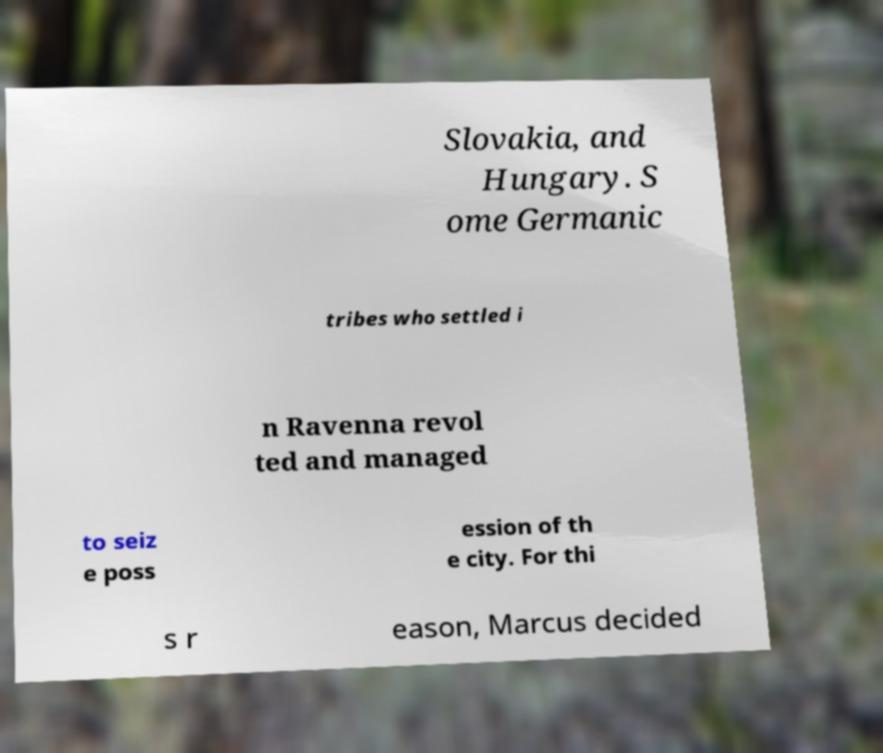Can you read and provide the text displayed in the image?This photo seems to have some interesting text. Can you extract and type it out for me? Slovakia, and Hungary. S ome Germanic tribes who settled i n Ravenna revol ted and managed to seiz e poss ession of th e city. For thi s r eason, Marcus decided 